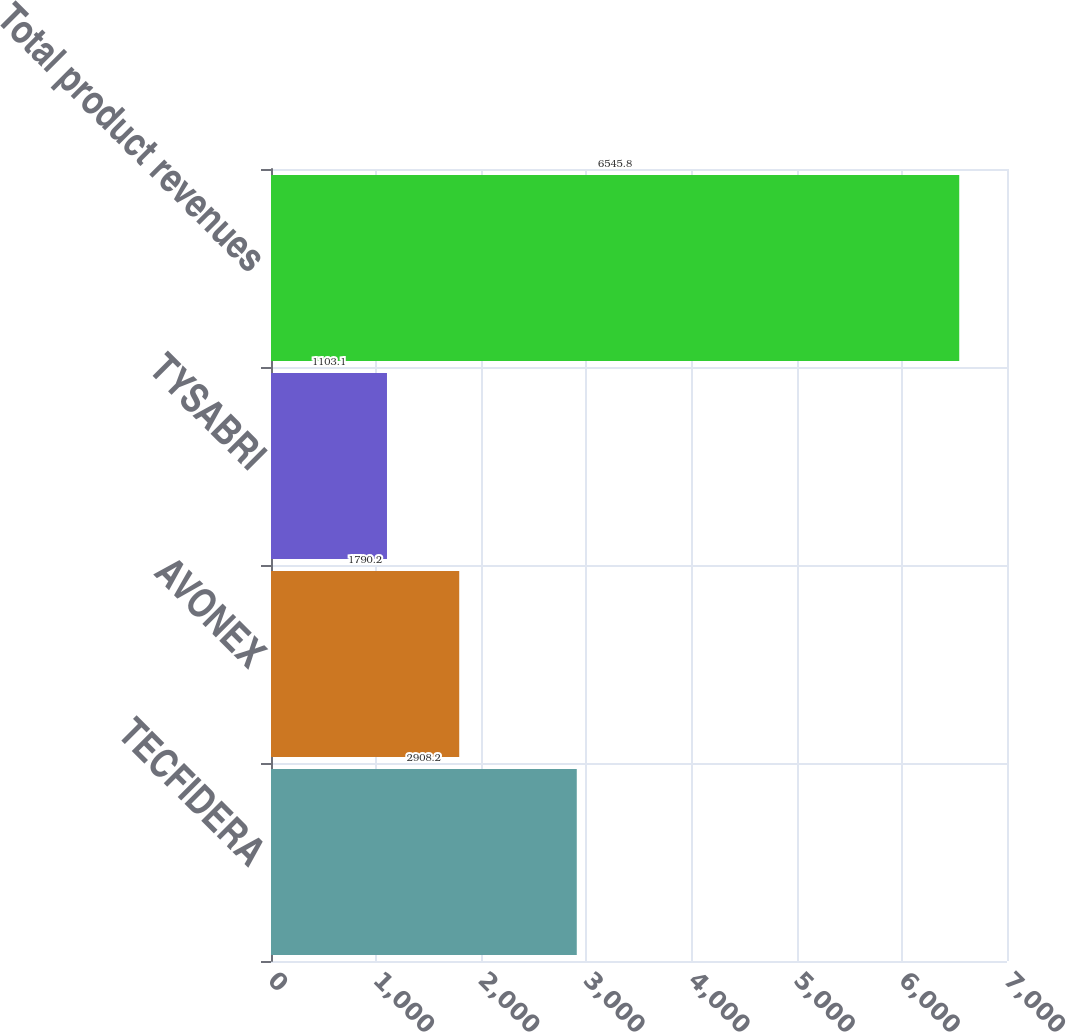Convert chart to OTSL. <chart><loc_0><loc_0><loc_500><loc_500><bar_chart><fcel>TECFIDERA<fcel>AVONEX<fcel>TYSABRI<fcel>Total product revenues<nl><fcel>2908.2<fcel>1790.2<fcel>1103.1<fcel>6545.8<nl></chart> 